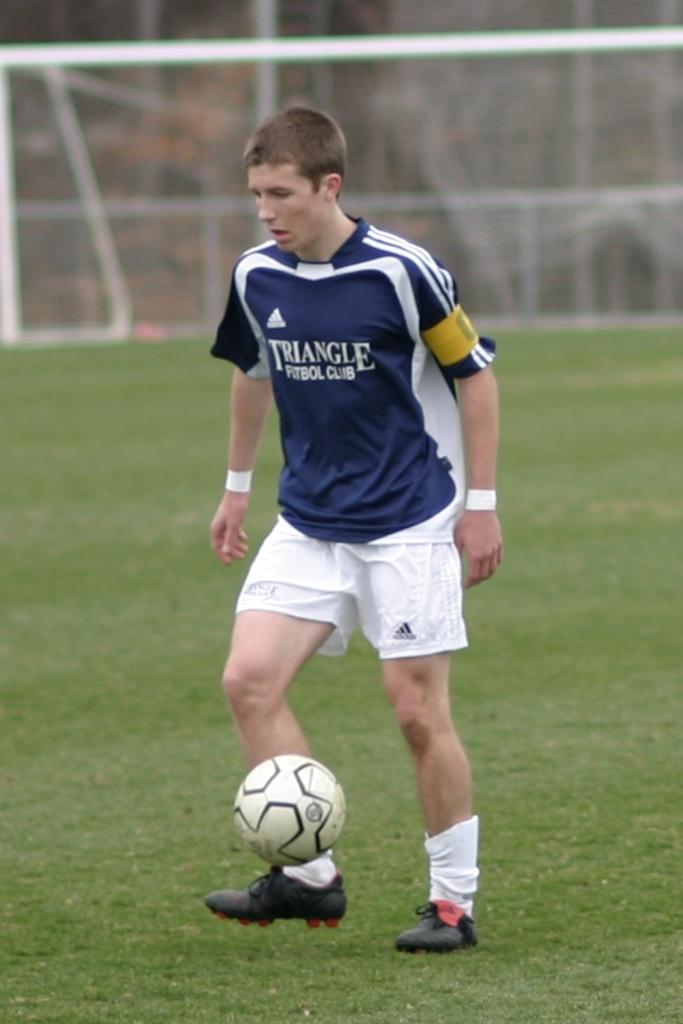<image>
Share a concise interpretation of the image provided. A Triangle Futbol club players is kicking a ball. 